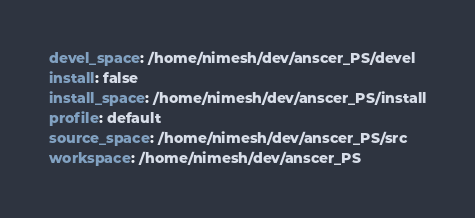<code> <loc_0><loc_0><loc_500><loc_500><_YAML_>devel_space: /home/nimesh/dev/anscer_PS/devel
install: false
install_space: /home/nimesh/dev/anscer_PS/install
profile: default
source_space: /home/nimesh/dev/anscer_PS/src
workspace: /home/nimesh/dev/anscer_PS
</code> 